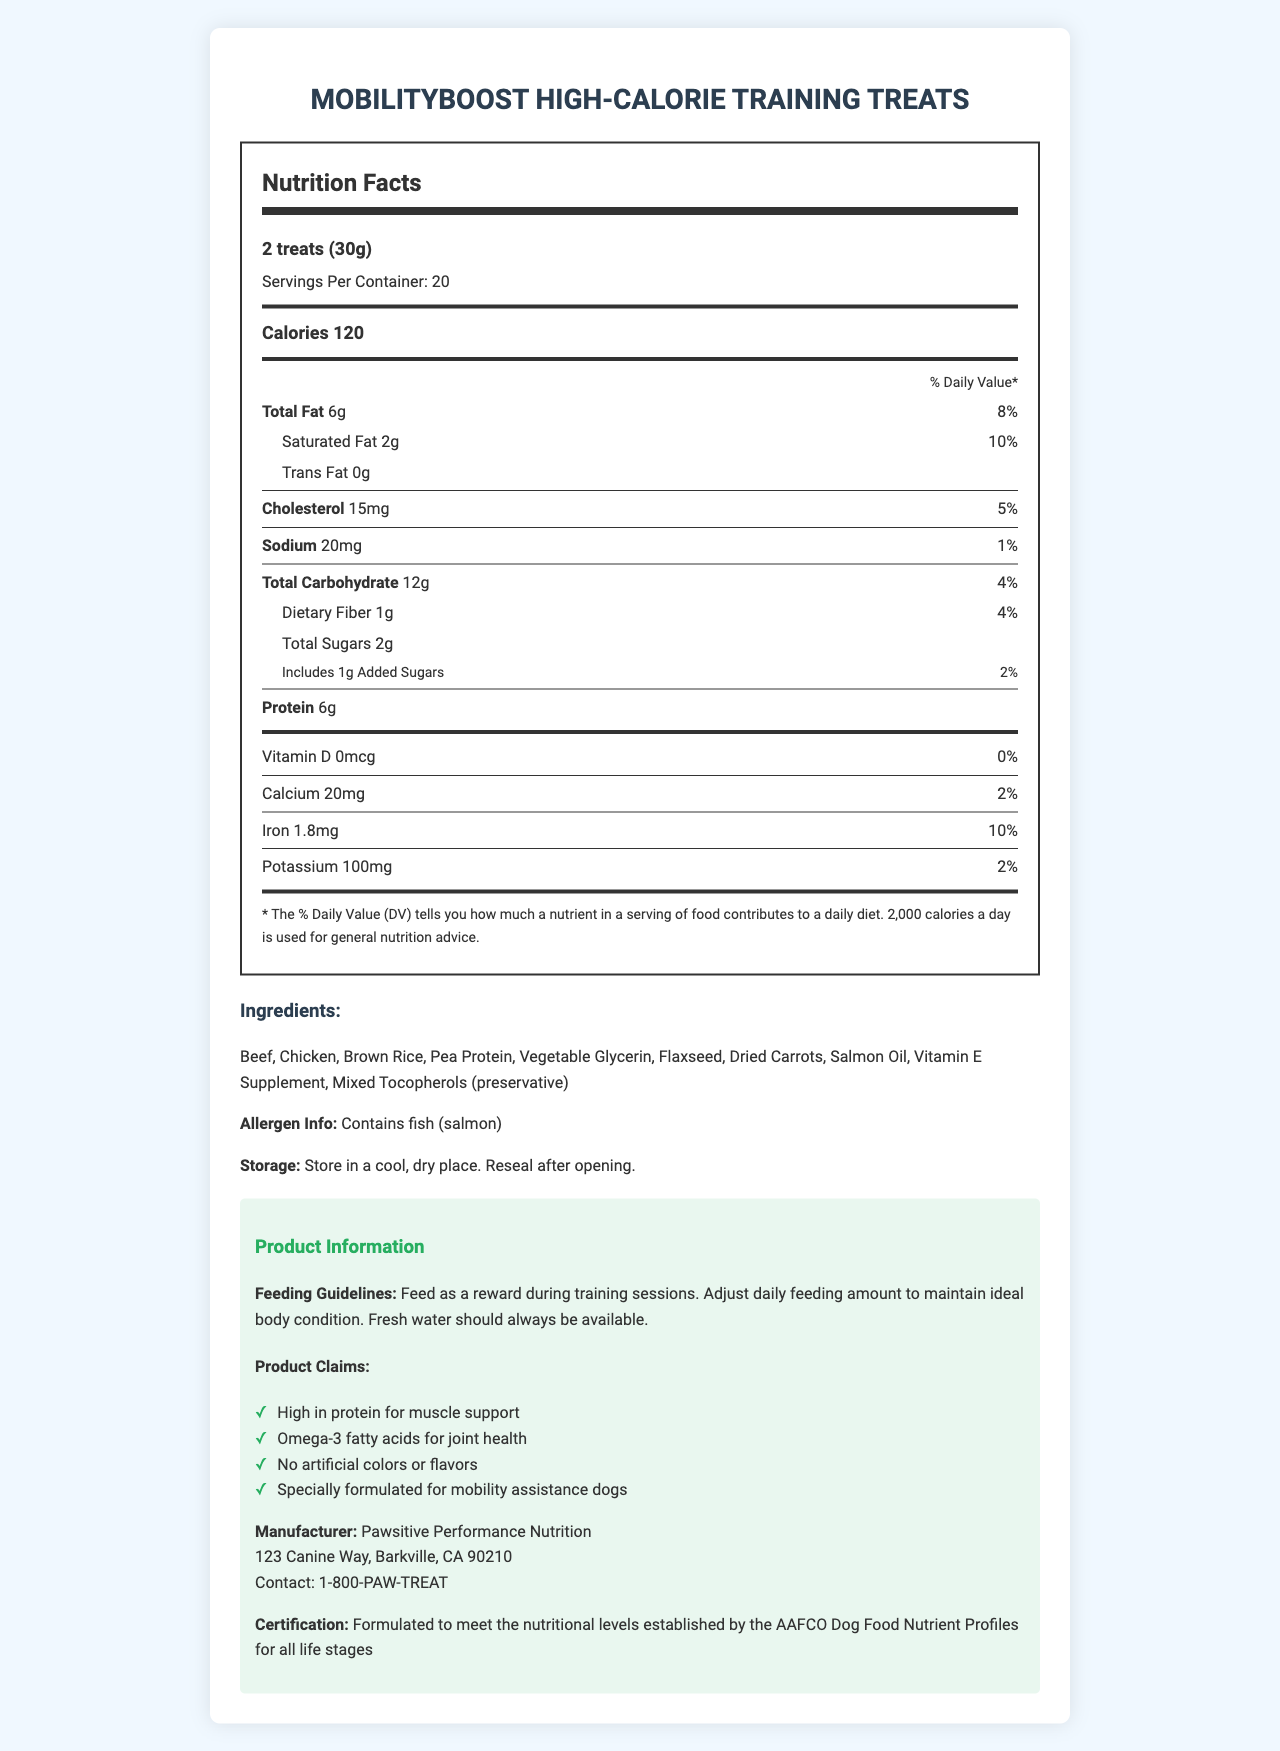what is the serving size of MobilityBoost High-Calorie Training Treats? The document states that the serving size is "2 treats (30g)".
Answer: 2 treats (30g) how many calories are in one serving of the treats? The "Nutrition Facts" section states that each serving contains 120 calories.
Answer: 120 calories how many grams of total fat does each serving contain? The "Nutrition Facts" section lists "Total Fat" as 6 grams per serving.
Answer: 6g how much protein is in a single serving? The "Nutrition Facts" section lists "Protein" as 6 grams per serving.
Answer: 6g what vitamins and minerals are mentioned in the document, along with their daily value percentages? The listing under "Nutrition Facts" mentions Vitamin D with 0%, Calcium with 2%, Iron with 10%, and Potassium with 2%.
Answer: Vitamin D (0%), Calcium (2%), Iron (10%), Potassium (2%) if a dog consumes four treats, what is the total calorie intake? A. 60 calories B. 120 calories C. 240 calories D. 480 calories Each serving (2 treats) is 120 calories. So, 4 treats equal 240 calories (120 calories x 2 servings).
Answer: C. 240 calories is there any trans fat in the treats? The "Nutrition Facts" section lists Trans Fat as 0g, indicating there is no trans fat.
Answer: No are there any artificial colors or flavors in MobilityBoost High-Calorie Training Treats? Under "Product Claims," it states that there are no artificial colors or flavors.
Answer: No what is the main idea of the document? The document includes various sections such as nutrition facts, ingredients, allergen information, storage instructions, feeding guidelines, product claims, manufacturer information, and certification details, all focusing on the product's suitability for mobility assistance dogs.
Answer: The document provides detailed nutritional information, ingredients, and product claims for MobilityBoost High-Calorie Training Treats, which are specially formulated for mobility assistance dogs. what is the daily value percentage of sodium in each serving? The "Nutrition Facts" section indicates that Sodium is 20mg per serving, which is 1% of the daily value.
Answer: 1% what should you do after opening the treat container? The storage instructions specify to reseal after opening.
Answer: Reseal after opening who manufactures MobilityBoost High-Calorie Training Treats? The manufacturer info in the document lists Pawsitive Performance Nutrition as the manufacturer.
Answer: Pawsitive Performance Nutrition what kinds of meat are used in these training treats? The ingredients list includes Beef and Chicken as the types of meat used.
Answer: Beef and Chicken can I find the production date of the treats in the document? The document provides extensive product information but does not include the production date of the treats.
Answer: Cannot be determined 